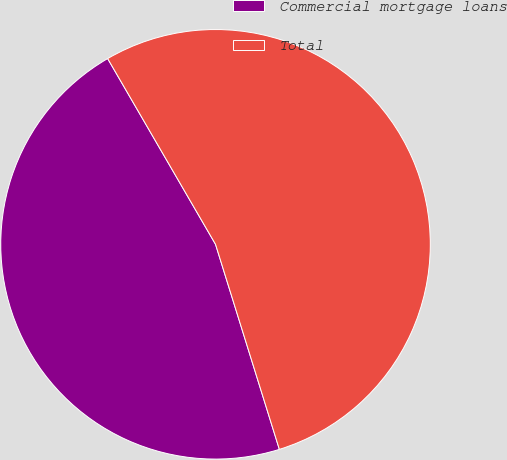<chart> <loc_0><loc_0><loc_500><loc_500><pie_chart><fcel>Commercial mortgage loans<fcel>Total<nl><fcel>46.43%<fcel>53.57%<nl></chart> 